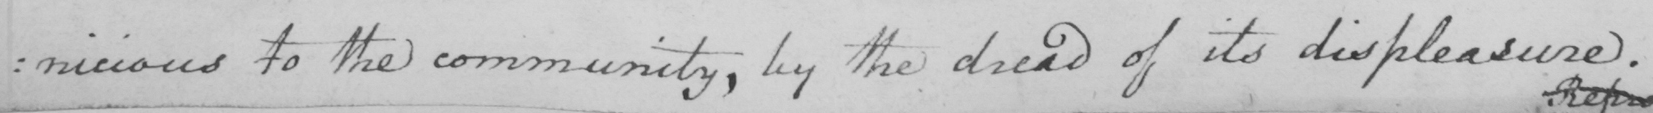Can you read and transcribe this handwriting? : nicious to the community , by the dread of its displeasure . 